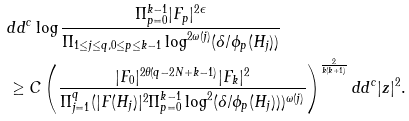Convert formula to latex. <formula><loc_0><loc_0><loc_500><loc_500>& d d ^ { c } \log \frac { \Pi _ { p = 0 } ^ { k - 1 } | F _ { p } | ^ { 2 \epsilon } } { \Pi _ { 1 \leq j \leq q , 0 \leq p \leq k - 1 } \log ^ { 2 \omega ( j ) } ( \delta / \phi _ { p } ( H _ { j } ) ) } \\ & \geq C \left ( \frac { | F _ { 0 } | ^ { 2 \theta ( q - 2 N + k - 1 ) } | F _ { k } | ^ { 2 } } { \Pi _ { j = 1 } ^ { q } ( | F ( H _ { j } ) | ^ { 2 } \Pi _ { p = 0 } ^ { k - 1 } \log ^ { 2 } ( \delta / \phi _ { p } ( H _ { j } ) ) ) ^ { \omega ( j ) } } \right ) ^ { \frac { 2 } { k ( k + 1 ) } } d d ^ { c } | z | ^ { 2 } .</formula> 